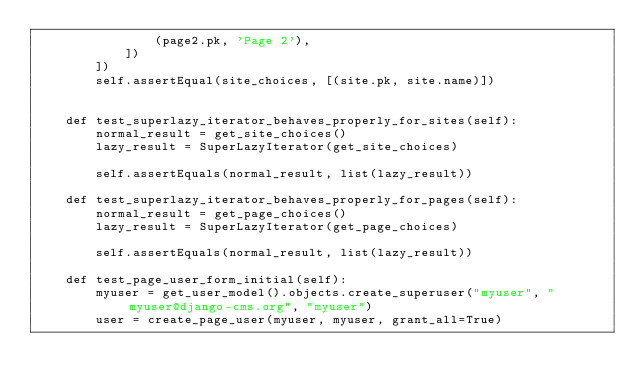<code> <loc_0><loc_0><loc_500><loc_500><_Python_>                (page2.pk, 'Page 2'),
            ])
        ])
        self.assertEqual(site_choices, [(site.pk, site.name)])


    def test_superlazy_iterator_behaves_properly_for_sites(self):
        normal_result = get_site_choices()
        lazy_result = SuperLazyIterator(get_site_choices)

        self.assertEquals(normal_result, list(lazy_result))

    def test_superlazy_iterator_behaves_properly_for_pages(self):
        normal_result = get_page_choices()
        lazy_result = SuperLazyIterator(get_page_choices)

        self.assertEquals(normal_result, list(lazy_result))

    def test_page_user_form_initial(self):
        myuser = get_user_model().objects.create_superuser("myuser", "myuser@django-cms.org", "myuser")
        user = create_page_user(myuser, myuser, grant_all=True)</code> 